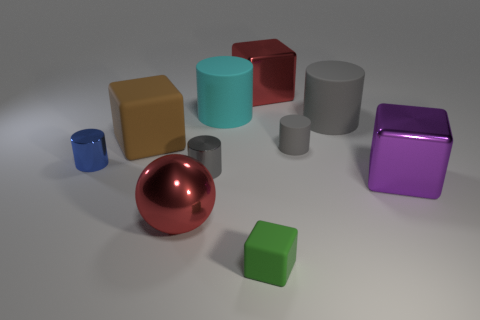Is the color of the tiny matte block the same as the big metal ball?
Your response must be concise. No. There is a purple block that is to the right of the gray cylinder to the left of the green object; what is its material?
Your answer should be compact. Metal. The purple object is what size?
Provide a succinct answer. Large. The green block that is the same material as the big cyan cylinder is what size?
Ensure brevity in your answer.  Small. There is a rubber block that is behind the purple cube; does it have the same size as the blue thing?
Provide a succinct answer. No. What shape is the gray object to the left of the big metal thing behind the small gray metallic thing in front of the brown rubber block?
Your answer should be compact. Cylinder. How many things are either cyan spheres or large red objects that are behind the big metal ball?
Keep it short and to the point. 1. What is the size of the cube behind the big brown object?
Provide a succinct answer. Large. There is a large object that is the same color as the metal ball; what shape is it?
Make the answer very short. Cube. Is the large purple cube made of the same material as the tiny blue cylinder that is to the left of the purple metallic block?
Your response must be concise. Yes. 